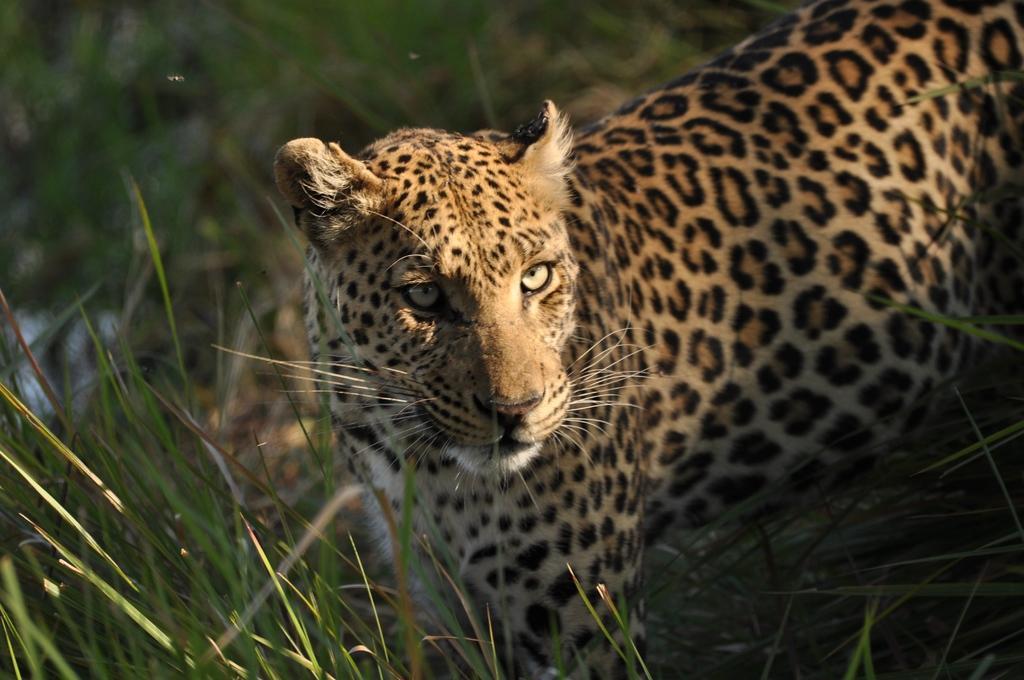Please provide a concise description of this image. As we can see in the image there is grass and chita. 